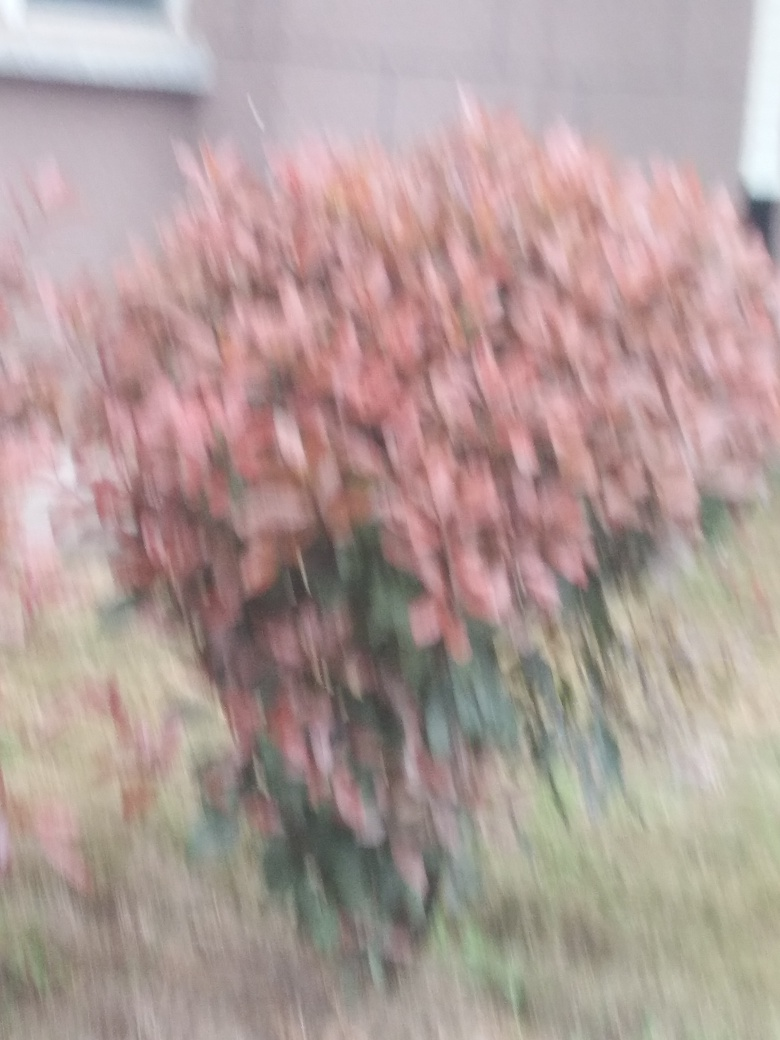What is the issue with this image quality?
A. Serious focus issues resulting in blurriness.
B. Overexposed highlights in the image.
C. Excessive noise in the image.
Answer with the option's letter from the given choices directly.
 A. 